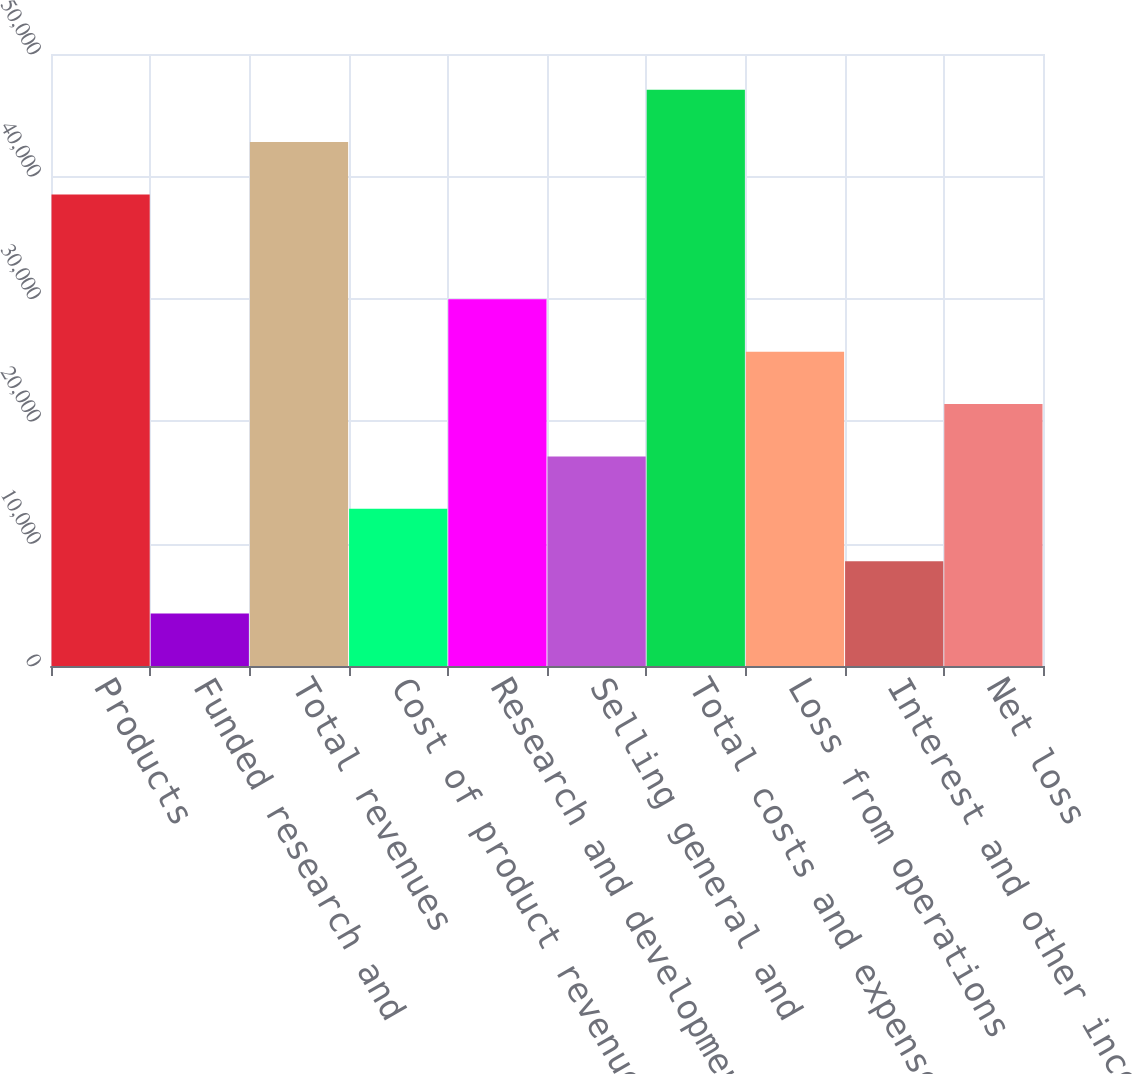<chart> <loc_0><loc_0><loc_500><loc_500><bar_chart><fcel>Products<fcel>Funded research and<fcel>Total revenues<fcel>Cost of product revenues<fcel>Research and development 1<fcel>Selling general and<fcel>Total costs and expenses<fcel>Loss from operations<fcel>Interest and other income net<fcel>Net loss<nl><fcel>38521<fcel>4280.88<fcel>42801<fcel>12840.9<fcel>29960.9<fcel>17120.9<fcel>47081<fcel>25680.9<fcel>8560.89<fcel>21400.9<nl></chart> 